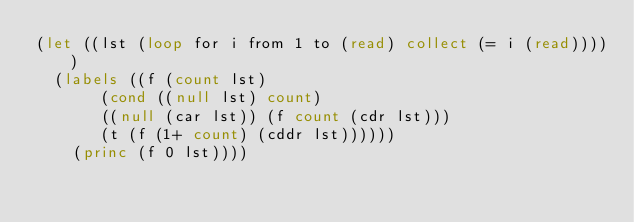<code> <loc_0><loc_0><loc_500><loc_500><_Lisp_>(let ((lst (loop for i from 1 to (read)	collect (= i (read)))))
  (labels ((f (count lst)
	     (cond ((null lst) count)
		   ((null (car lst)) (f count (cdr lst)))
		   (t (f (1+ count) (cddr lst))))))
    (princ (f 0 lst))))</code> 